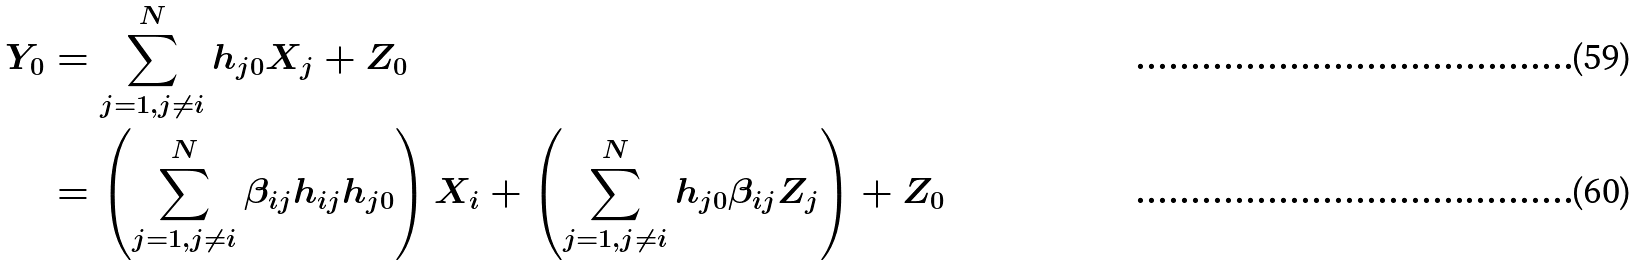<formula> <loc_0><loc_0><loc_500><loc_500>Y _ { 0 } & = \sum _ { j = 1 , j \neq i } ^ { N } h _ { j 0 } X _ { j } + Z _ { 0 } \\ & = \left ( \sum _ { j = 1 , j \neq i } ^ { N } \beta _ { i j } h _ { i j } h _ { j 0 } \right ) X _ { i } + \left ( \sum _ { j = 1 , j \neq i } ^ { N } h _ { j 0 } \beta _ { i j } Z _ { j } \right ) + Z _ { 0 }</formula> 